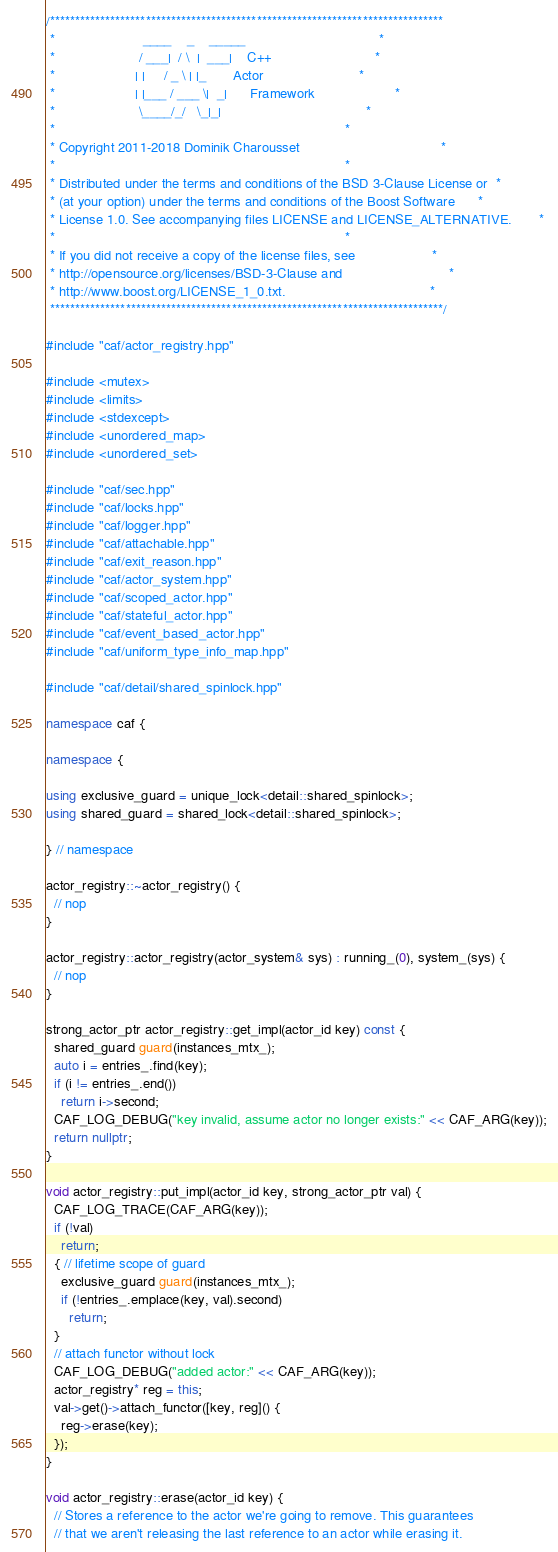Convert code to text. <code><loc_0><loc_0><loc_500><loc_500><_C++_>/******************************************************************************
 *                       ____    _    _____                                   *
 *                      / ___|  / \  |  ___|    C++                           *
 *                     | |     / _ \ | |_       Actor                         *
 *                     | |___ / ___ \|  _|      Framework                     *
 *                      \____/_/   \_|_|                                      *
 *                                                                            *
 * Copyright 2011-2018 Dominik Charousset                                     *
 *                                                                            *
 * Distributed under the terms and conditions of the BSD 3-Clause License or  *
 * (at your option) under the terms and conditions of the Boost Software      *
 * License 1.0. See accompanying files LICENSE and LICENSE_ALTERNATIVE.       *
 *                                                                            *
 * If you did not receive a copy of the license files, see                    *
 * http://opensource.org/licenses/BSD-3-Clause and                            *
 * http://www.boost.org/LICENSE_1_0.txt.                                      *
 ******************************************************************************/

#include "caf/actor_registry.hpp"

#include <mutex>
#include <limits>
#include <stdexcept>
#include <unordered_map>
#include <unordered_set>

#include "caf/sec.hpp"
#include "caf/locks.hpp"
#include "caf/logger.hpp"
#include "caf/attachable.hpp"
#include "caf/exit_reason.hpp"
#include "caf/actor_system.hpp"
#include "caf/scoped_actor.hpp"
#include "caf/stateful_actor.hpp"
#include "caf/event_based_actor.hpp"
#include "caf/uniform_type_info_map.hpp"

#include "caf/detail/shared_spinlock.hpp"

namespace caf {

namespace {

using exclusive_guard = unique_lock<detail::shared_spinlock>;
using shared_guard = shared_lock<detail::shared_spinlock>;

} // namespace

actor_registry::~actor_registry() {
  // nop
}

actor_registry::actor_registry(actor_system& sys) : running_(0), system_(sys) {
  // nop
}

strong_actor_ptr actor_registry::get_impl(actor_id key) const {
  shared_guard guard(instances_mtx_);
  auto i = entries_.find(key);
  if (i != entries_.end())
    return i->second;
  CAF_LOG_DEBUG("key invalid, assume actor no longer exists:" << CAF_ARG(key));
  return nullptr;
}

void actor_registry::put_impl(actor_id key, strong_actor_ptr val) {
  CAF_LOG_TRACE(CAF_ARG(key));
  if (!val)
    return;
  { // lifetime scope of guard
    exclusive_guard guard(instances_mtx_);
    if (!entries_.emplace(key, val).second)
      return;
  }
  // attach functor without lock
  CAF_LOG_DEBUG("added actor:" << CAF_ARG(key));
  actor_registry* reg = this;
  val->get()->attach_functor([key, reg]() {
    reg->erase(key);
  });
}

void actor_registry::erase(actor_id key) {
  // Stores a reference to the actor we're going to remove. This guarantees
  // that we aren't releasing the last reference to an actor while erasing it.</code> 